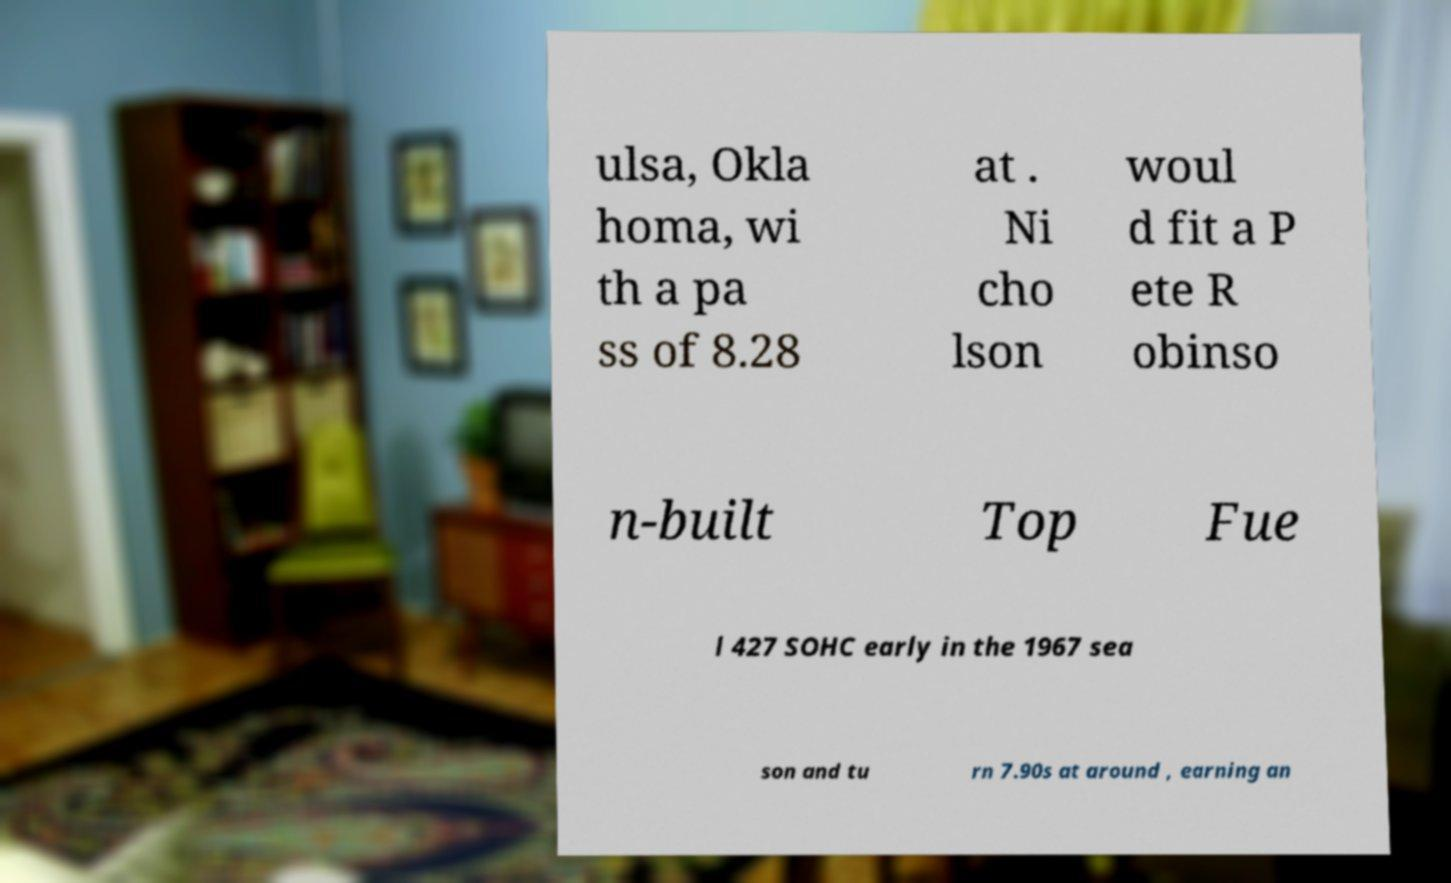Can you read and provide the text displayed in the image?This photo seems to have some interesting text. Can you extract and type it out for me? ulsa, Okla homa, wi th a pa ss of 8.28 at . Ni cho lson woul d fit a P ete R obinso n-built Top Fue l 427 SOHC early in the 1967 sea son and tu rn 7.90s at around , earning an 